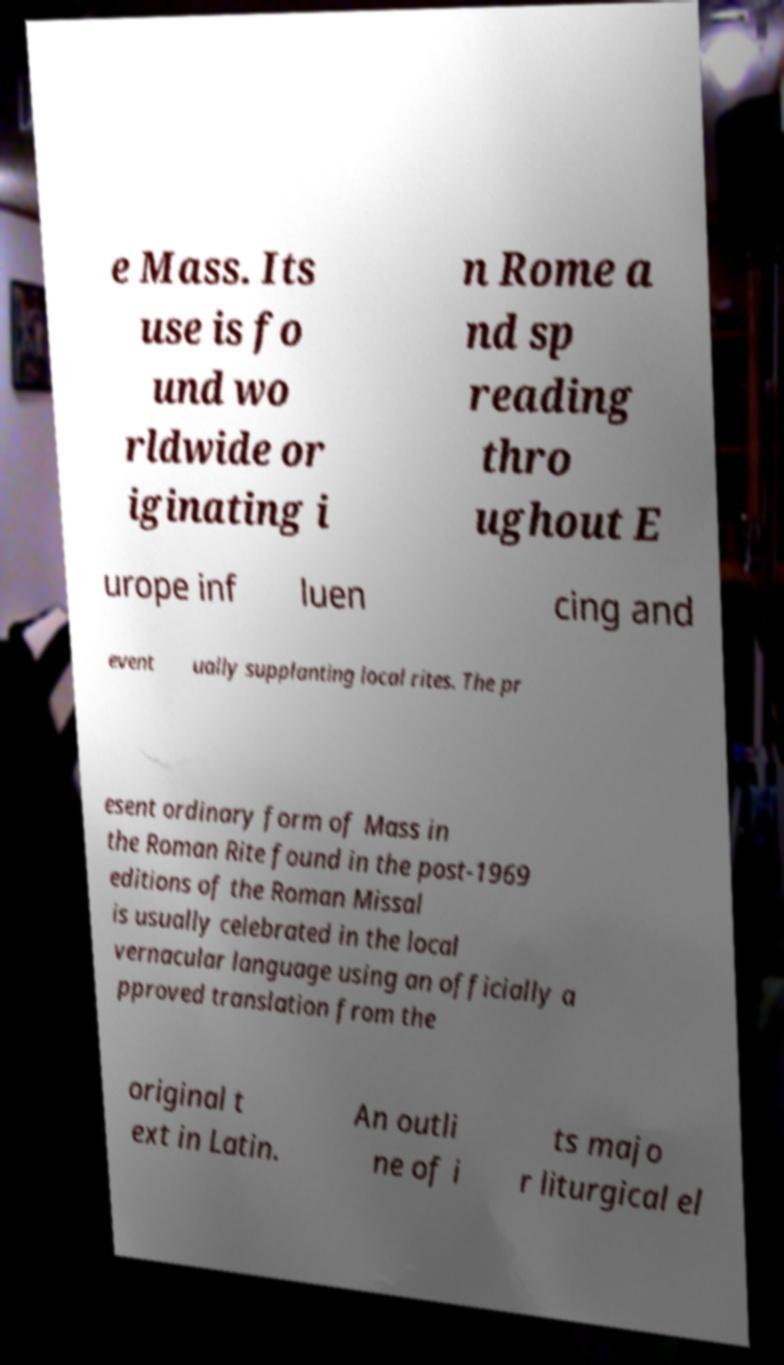What messages or text are displayed in this image? I need them in a readable, typed format. e Mass. Its use is fo und wo rldwide or iginating i n Rome a nd sp reading thro ughout E urope inf luen cing and event ually supplanting local rites. The pr esent ordinary form of Mass in the Roman Rite found in the post-1969 editions of the Roman Missal is usually celebrated in the local vernacular language using an officially a pproved translation from the original t ext in Latin. An outli ne of i ts majo r liturgical el 